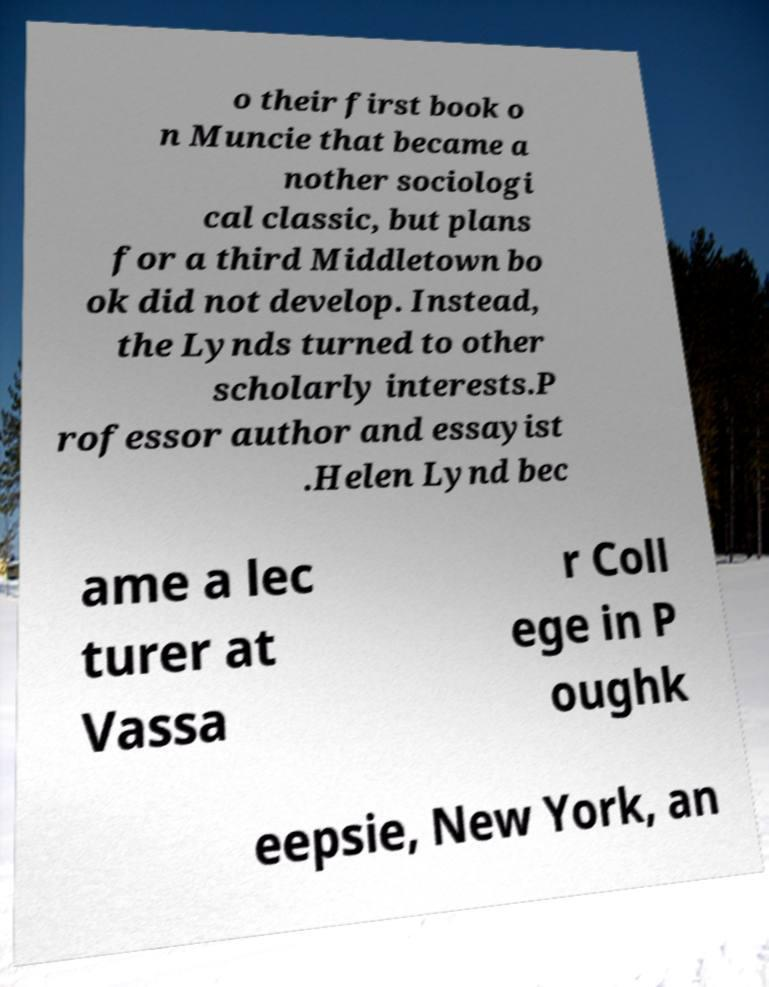Can you read and provide the text displayed in the image?This photo seems to have some interesting text. Can you extract and type it out for me? o their first book o n Muncie that became a nother sociologi cal classic, but plans for a third Middletown bo ok did not develop. Instead, the Lynds turned to other scholarly interests.P rofessor author and essayist .Helen Lynd bec ame a lec turer at Vassa r Coll ege in P oughk eepsie, New York, an 